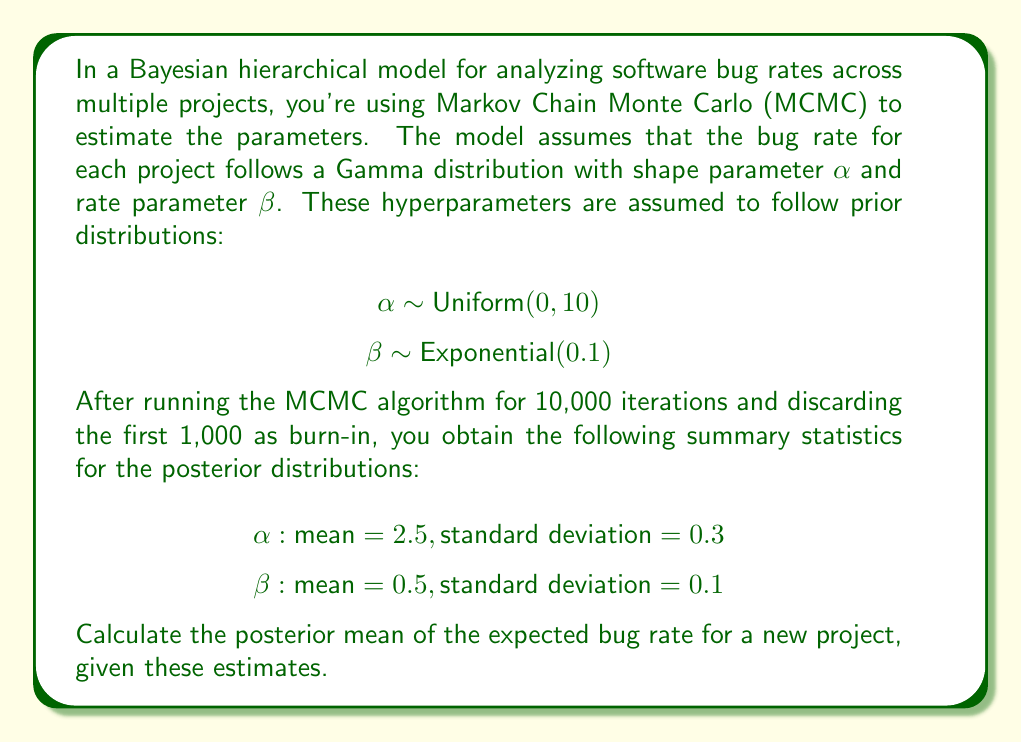Help me with this question. To solve this problem, we'll follow these steps:

1) In a Gamma distribution, the expected value (mean) is given by $\frac{\alpha}{\beta}$.

2) We need to calculate $E[\frac{\alpha}{\beta}]$ using the posterior means of $\alpha$ and $\beta$.

3) However, simply dividing the posterior means $\frac{E[\alpha]}{E[\beta]}$ is not correct due to Jensen's inequality.

4) Instead, we can use a second-order Taylor expansion to approximate $E[\frac{\alpha}{\beta}]$:

   $$E[\frac{\alpha}{\beta}] \approx \frac{E[\alpha]}{E[\beta]} + \frac{\text{Var}(\beta)E[\alpha]}{E[\beta]^3} - \frac{\text{Cov}(\alpha,\beta)}{E[\beta]^2}$$

5) We're given $E[\alpha] = 2.5$ and $E[\beta] = 0.5$.

6) $\text{Var}(\beta) = 0.1^2 = 0.01$

7) We don't have information about the covariance between $\alpha$ and $\beta$, so we'll assume they're independent and set $\text{Cov}(\alpha,\beta) = 0$.

8) Plugging these values into the formula:

   $$E[\frac{\alpha}{\beta}] \approx \frac{2.5}{0.5} + \frac{0.01 \cdot 2.5}{0.5^3} - 0$$
   
   $$= 5 + \frac{0.025}{0.125} = 5 + 0.2 = 5.2$$

Therefore, the posterior mean of the expected bug rate for a new project is approximately 5.2.
Answer: 5.2 